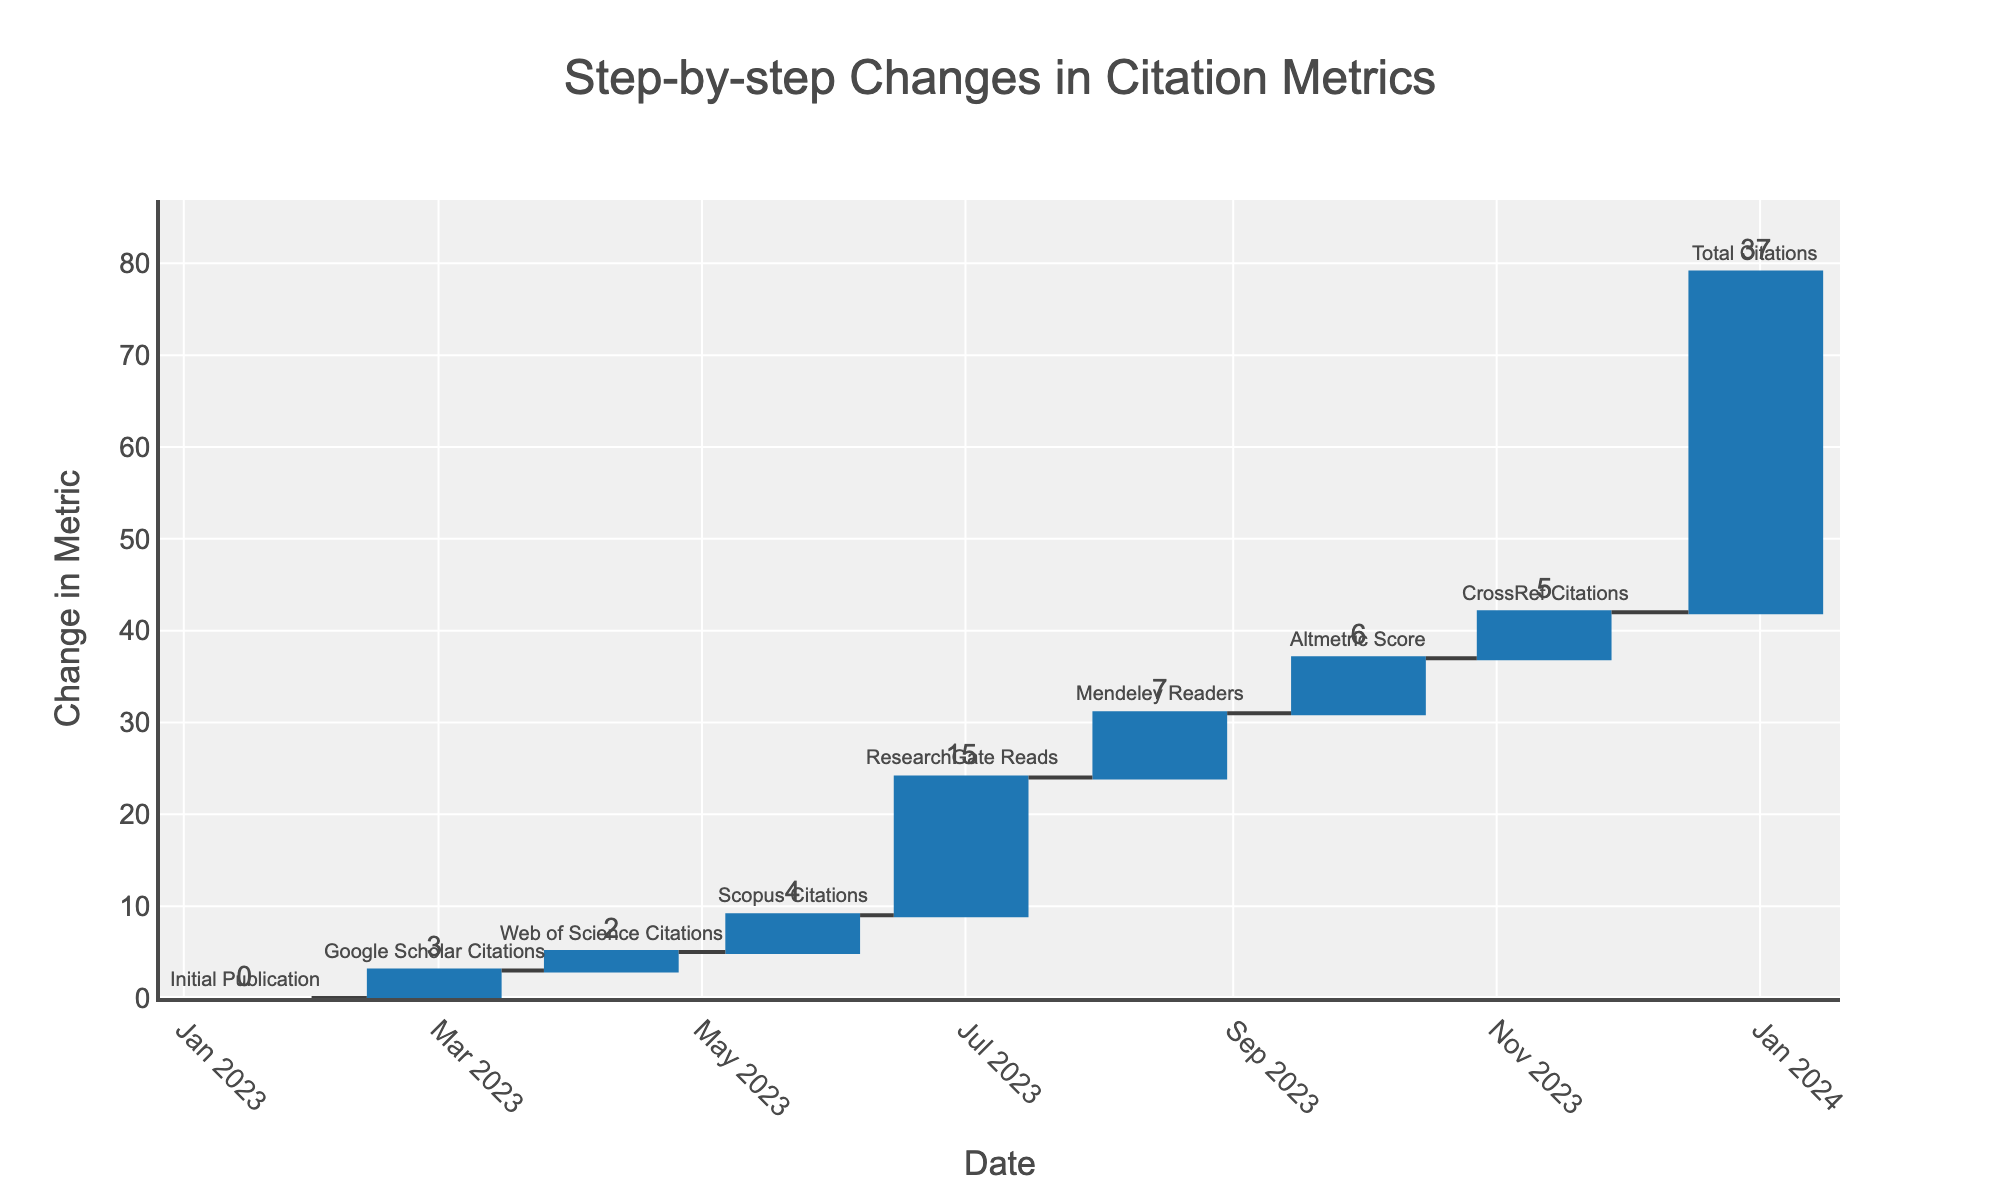What is the title of the Waterfall Chart? The title of the chart is displayed at the top of the figure.
Answer: "Step-by-step Changes in Citation Metrics" How many data points are shown on the Waterfall Chart? Each date on the x-axis has a corresponding point, and there are 9 dates listed in the data.
Answer: 9 Which citation metric had the largest change in the chart? By looking at the size of the bars, ResearchGate Reads had the largest bar, indicating the largest change.
Answer: ResearchGate Reads What is the change in the Altmetric Score? The change value for Altmetric Score is marked at 6 next to the corresponding bar.
Answer: 6 What is the cumulative change in citations by November 12, 2023? The cumulative change is shown on the y-axis where the CrossRef Citations bar ends, which is marked as a total of 37.
Answer: 37 Which metric shows the first change in the chart after the initial publication? After the Initial Publication (0 change), the next metric is Google Scholar Citations with a change of 3.
Answer: Google Scholar Citations How does the change in Mendeley Readers compare to Web of Science Citations? Mendeley Readers show a change of 7, whereas Web of Science Citations show a change of 2. Thus, Mendeley Readers changed by 5 more units.
Answer: Mendeley Readers changed by 5 more units What is the cumulative change by June 30, 2023? The changes up to June 30, 2023, are 0 (Initial) + 3 (Google Scholar) + 2 (Web of Science) + 4 (Scopus) + 15 (ResearchGate Reads), resulting in a total of 24.
Answer: 24 How many citation metrics had a positive change greater than 5? By counting the bars with changes greater than 5: ResearchGate Reads (15), Mendeley Readers (7), and Altmetric Score (6), we see there are three metrics.
Answer: 3 Which metric had the least impact on the total citations? By examining the bars, Web of Science Citations had the smallest change of 2.
Answer: Web of Science Citations 